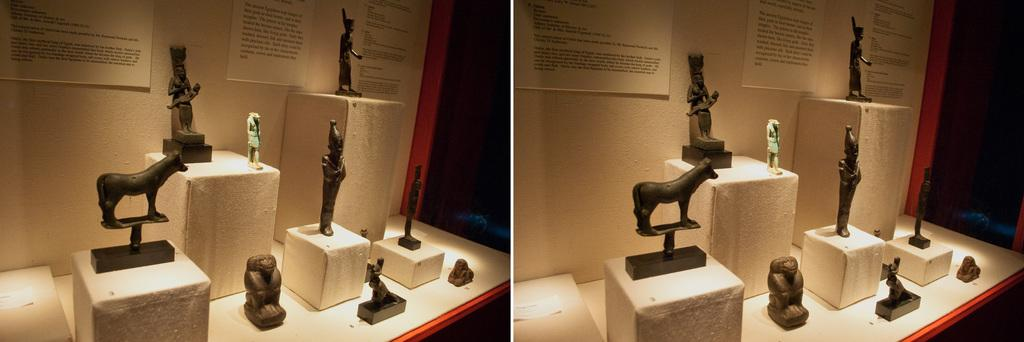What type of artwork is the image? The image is a collage. What piece of furniture is present in the image? There is a table in the image. What objects are placed on the table? Sculptures are placed on the table. What is placed on the walls in the image? There are boards placed on the walls. What type of oatmeal is served on the table in the image? There is no oatmeal present in the image; the table features sculptures instead. 